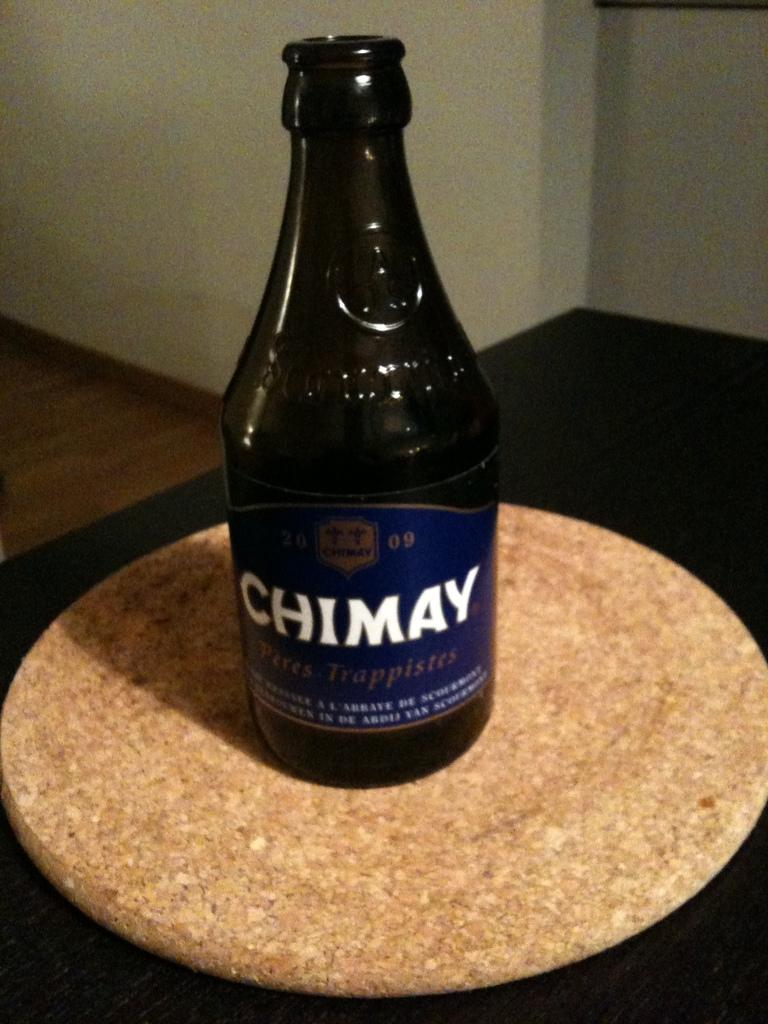<image>
Present a compact description of the photo's key features. A dark glass bottle of Chimay alcohol sits on a coaster on top of a black table. 